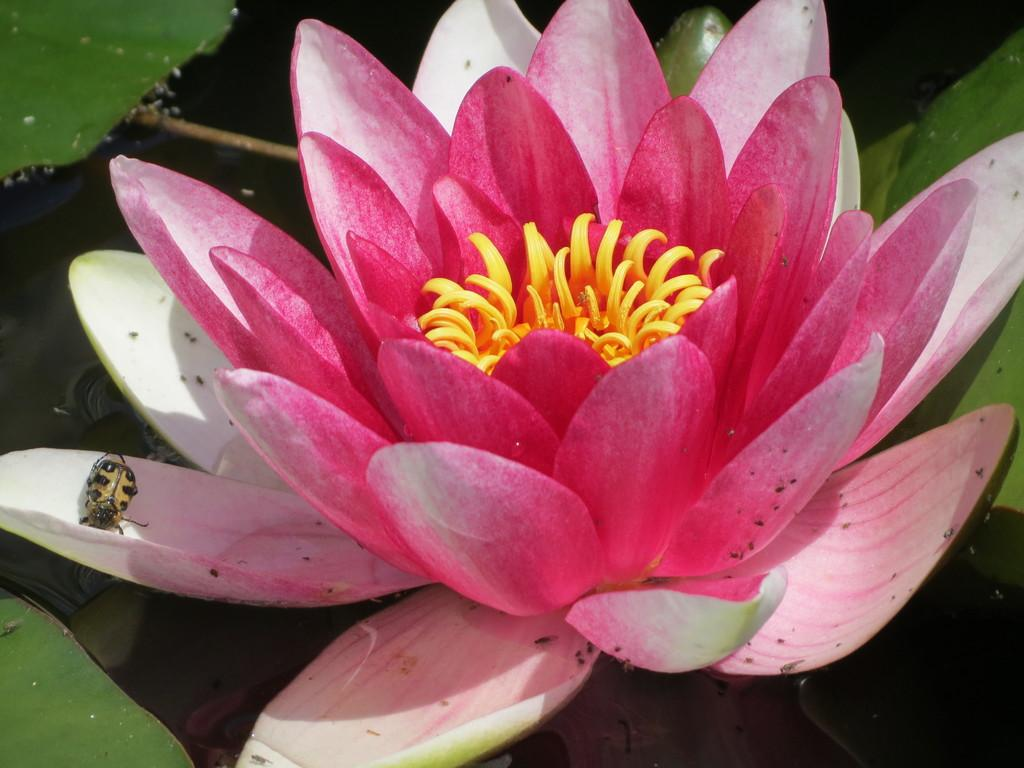What is one living organism that can be seen in the image? There is a flower in the image. What other living organism can be seen in the image? There is an insect in the image. What type of environment is depicted in the image? There are plants in the water in the image, which may suggest that the image was taken near a lake. What position does the writer take in the image? There is no writer present in the image. What idea is being conveyed by the insect in the image? The image does not convey any ideas or messages from the insect; it is simply an insect in the image. 